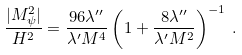Convert formula to latex. <formula><loc_0><loc_0><loc_500><loc_500>\frac { | M _ { \psi } ^ { 2 } | } { H ^ { 2 } } = \frac { 9 6 \lambda ^ { \prime \prime } } { \lambda ^ { \prime } M ^ { 4 } } \left ( 1 + \frac { 8 \lambda ^ { \prime \prime } } { \lambda ^ { \prime } M ^ { 2 } } \right ) ^ { - 1 } \, .</formula> 